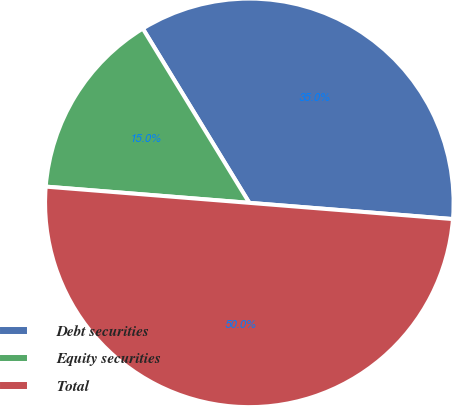Convert chart. <chart><loc_0><loc_0><loc_500><loc_500><pie_chart><fcel>Debt securities<fcel>Equity securities<fcel>Total<nl><fcel>35.0%<fcel>15.0%<fcel>50.0%<nl></chart> 